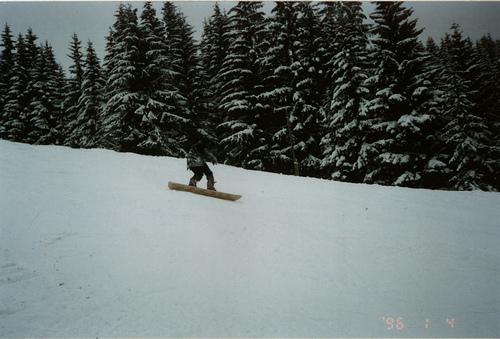Is this snowboarding?
Concise answer only. Yes. What is the skier on?
Write a very short answer. Snowboard. Is it a clear day or overcast?
Keep it brief. Overcast. Is this a safe sport?
Keep it brief. Yes. Is his snowboard on the ground?
Keep it brief. Yes. What type of trees are behind the snowboarder?
Short answer required. Pine. What type of skiing are they doing?
Short answer required. Snowboarding. What sport is this person participating in?
Short answer required. Snowboarding. Is there any shadows of plants in the image?
Be succinct. No. What is this person doing?
Answer briefly. Snowboarding. Is there a snowboard?
Answer briefly. Yes. Is this person snowboarding?
Write a very short answer. Yes. 